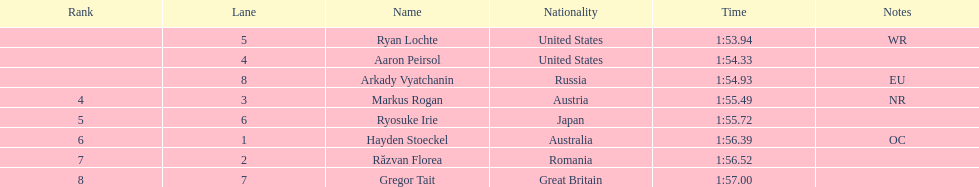How much time did it require for ryosuke irie to finish? 1:55.72. 